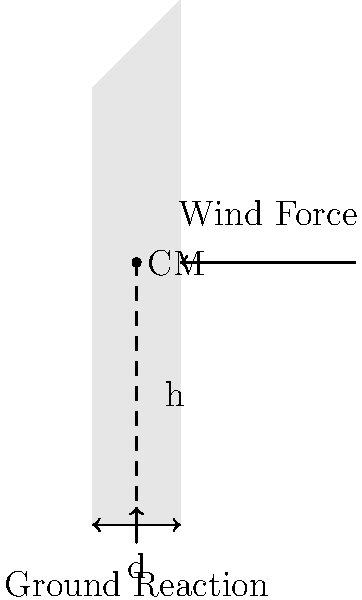A cylindrical lighthouse tower with a height of 30 meters and a base diameter of 6 meters is subjected to a uniform wind force of 2000 N acting at its center of mass. Calculate the minimum coefficient of static friction required between the lighthouse base and the ground to prevent the tower from tipping over. Assume the center of mass is located at half the height of the tower. Let's approach this problem step-by-step:

1) First, we need to understand the forces acting on the lighthouse:
   - Wind force (F) = 2000 N
   - Weight of the lighthouse (W) (acting downward at the center of mass)
   - Normal force (N) from the ground
   - Friction force (f) at the base

2) For tipping to occur, the moment caused by the wind force must be countered by the moment due to the lighthouse's weight.

3) The moment arm for the wind force is half the height of the tower:
   $h = 30/2 = 15$ meters

4) The moment arm for the weight is half the diameter of the base:
   $d/2 = 6/2 = 3$ meters

5) At the point of tipping, these moments are equal:
   $F \cdot h = W \cdot (d/2)$

6) We don't know W, but we know that at this point, the normal force N will be concentrated at the edge of the base. The friction force f will be at its maximum, $f = \mu N$, where $\mu$ is the coefficient of static friction.

7) For equilibrium in the horizontal direction:
   $F = f = \mu N$

8) For equilibrium in the vertical direction:
   $N = W$

9) Substituting these into the moment equation:
   $F \cdot h = N \cdot (d/2)$
   $2000 \cdot 15 = N \cdot 3$
   $N = 10000$ N

10) Now we can find $\mu$:
    $\mu = F/N = 2000/10000 = 0.2$

Therefore, the minimum coefficient of static friction required is 0.2.
Answer: 0.2 